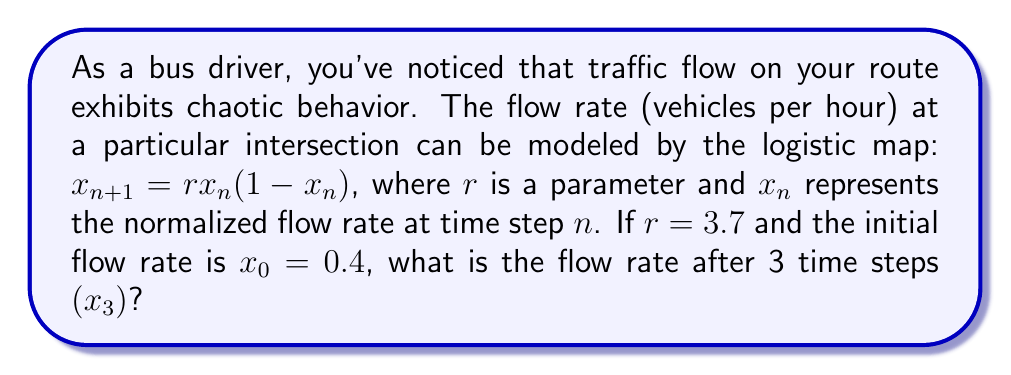Provide a solution to this math problem. To solve this problem, we need to iterate the logistic map equation three times:

1. First iteration (n = 0 to n = 1):
   $x_1 = rx_0(1-x_0)$
   $x_1 = 3.7 \cdot 0.4 \cdot (1-0.4)$
   $x_1 = 3.7 \cdot 0.4 \cdot 0.6 = 0.888$

2. Second iteration (n = 1 to n = 2):
   $x_2 = rx_1(1-x_1)$
   $x_2 = 3.7 \cdot 0.888 \cdot (1-0.888)$
   $x_2 = 3.7 \cdot 0.888 \cdot 0.112 \approx 0.3682$

3. Third iteration (n = 2 to n = 3):
   $x_3 = rx_2(1-x_2)$
   $x_3 = 3.7 \cdot 0.3682 \cdot (1-0.3682)$
   $x_3 = 3.7 \cdot 0.3682 \cdot 0.6318 \approx 0.8617$

Therefore, the flow rate after 3 time steps $(x_3)$ is approximately 0.8617.
Answer: 0.8617 